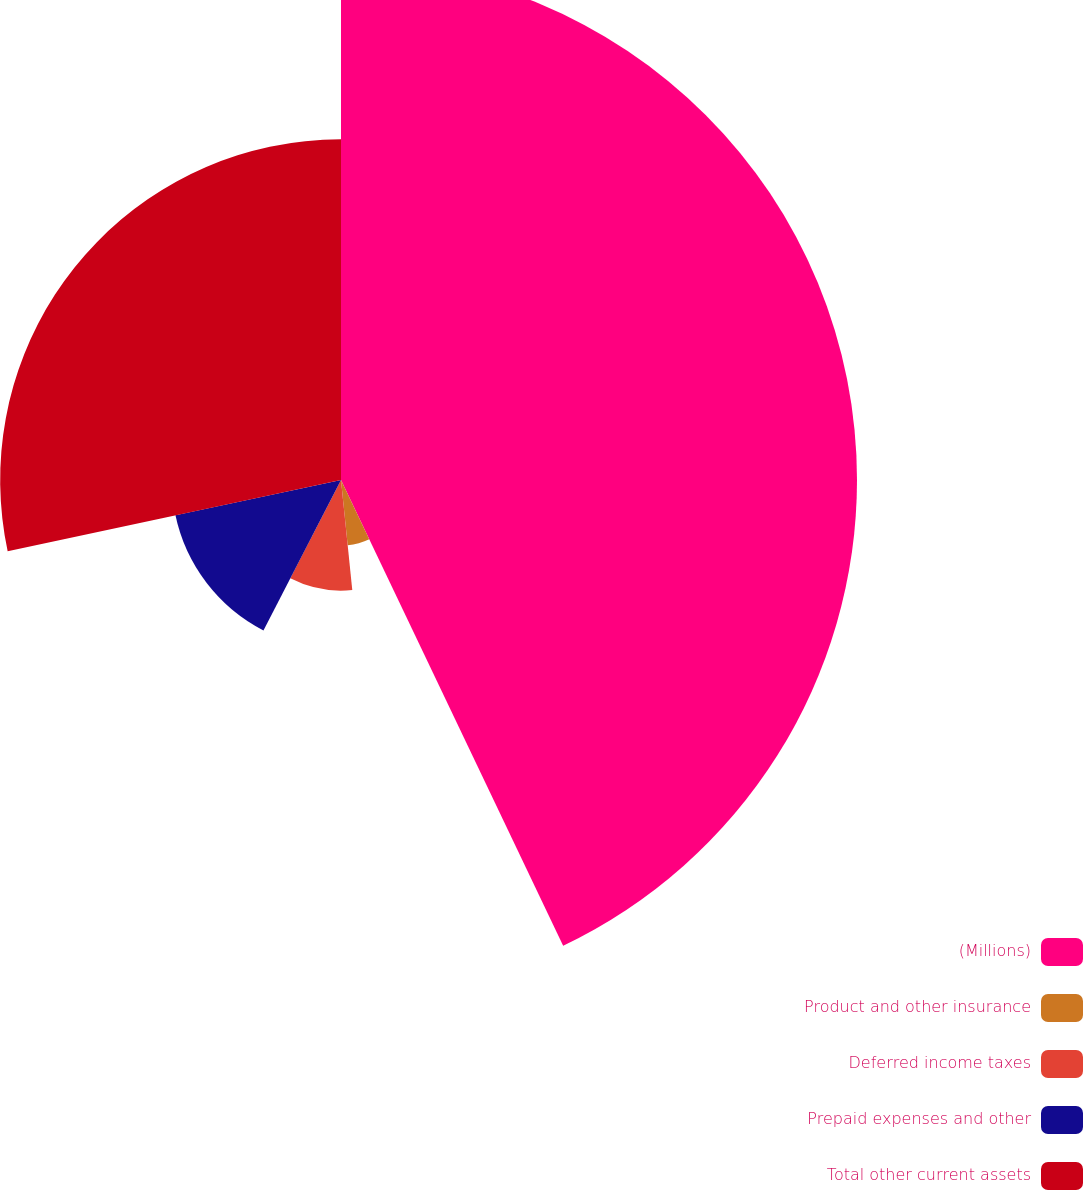Convert chart to OTSL. <chart><loc_0><loc_0><loc_500><loc_500><pie_chart><fcel>(Millions)<fcel>Product and other insurance<fcel>Deferred income taxes<fcel>Prepaid expenses and other<fcel>Total other current assets<nl><fcel>42.92%<fcel>5.46%<fcel>9.2%<fcel>14.08%<fcel>28.35%<nl></chart> 